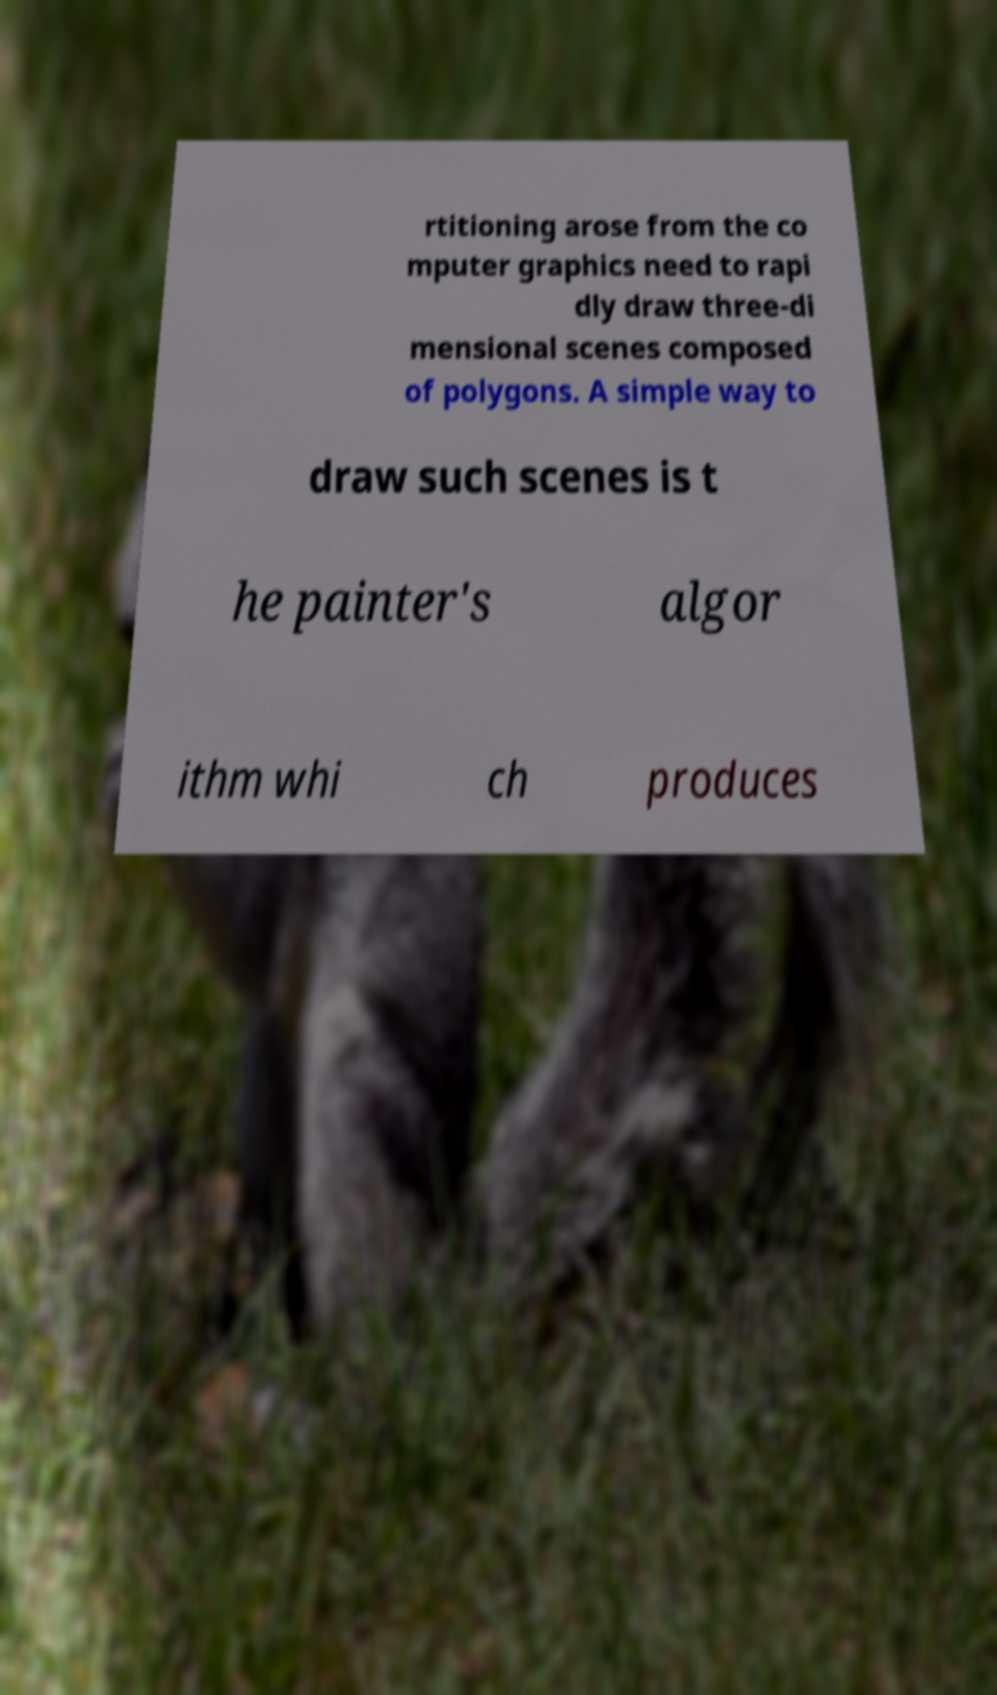What messages or text are displayed in this image? I need them in a readable, typed format. rtitioning arose from the co mputer graphics need to rapi dly draw three-di mensional scenes composed of polygons. A simple way to draw such scenes is t he painter's algor ithm whi ch produces 